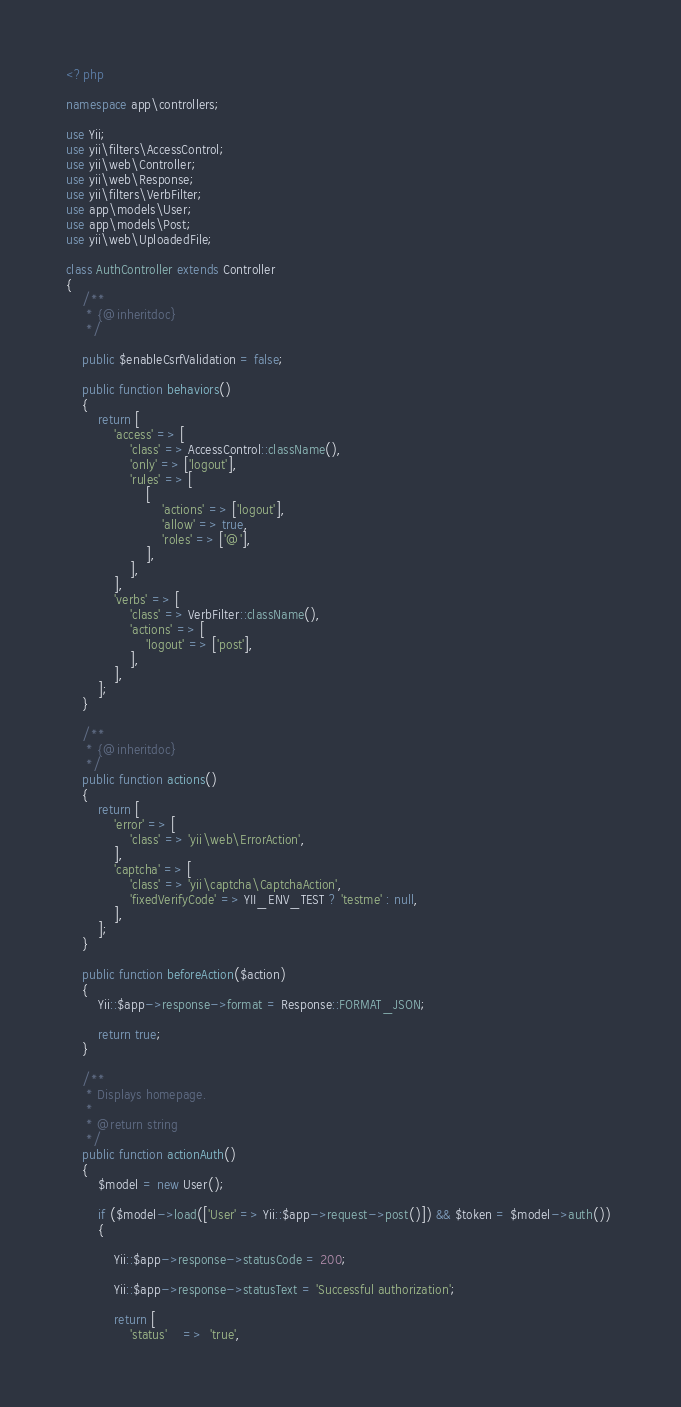Convert code to text. <code><loc_0><loc_0><loc_500><loc_500><_PHP_><?php

namespace app\controllers;

use Yii;
use yii\filters\AccessControl;
use yii\web\Controller;
use yii\web\Response;
use yii\filters\VerbFilter;
use app\models\User;
use app\models\Post;
use yii\web\UploadedFile;

class AuthController extends Controller
{
    /**
     * {@inheritdoc}
     */

    public $enableCsrfValidation = false;

    public function behaviors()
    {
        return [
            'access' => [
                'class' => AccessControl::className(),
                'only' => ['logout'],
                'rules' => [
                    [
                        'actions' => ['logout'],
                        'allow' => true,
                        'roles' => ['@'],
                    ],
                ],
            ],
            'verbs' => [
                'class' => VerbFilter::className(),
                'actions' => [
                    'logout' => ['post'],
                ],
            ],
        ];
    }

    /**
     * {@inheritdoc}
     */
    public function actions()
    {
        return [
            'error' => [
                'class' => 'yii\web\ErrorAction',
            ],
            'captcha' => [
                'class' => 'yii\captcha\CaptchaAction',
                'fixedVerifyCode' => YII_ENV_TEST ? 'testme' : null,
            ],
        ];
    }

    public function beforeAction($action)
    {
        Yii::$app->response->format = Response::FORMAT_JSON;

        return true;
    }

    /**
     * Displays homepage.
     *
     * @return string
     */
    public function actionAuth()
    {      
        $model = new User();
        
        if ($model->load(['User' => Yii::$app->request->post()]) && $token = $model->auth()) 
        {

            Yii::$app->response->statusCode = 200;

            Yii::$app->response->statusText = 'Successful authorization';    

            return [
                'status'    =>  'true',</code> 